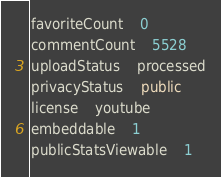<code> <loc_0><loc_0><loc_500><loc_500><_SQL_>favoriteCount	0
commentCount	5528
uploadStatus	processed
privacyStatus	public
license	youtube
embeddable	1
publicStatsViewable	1
</code> 